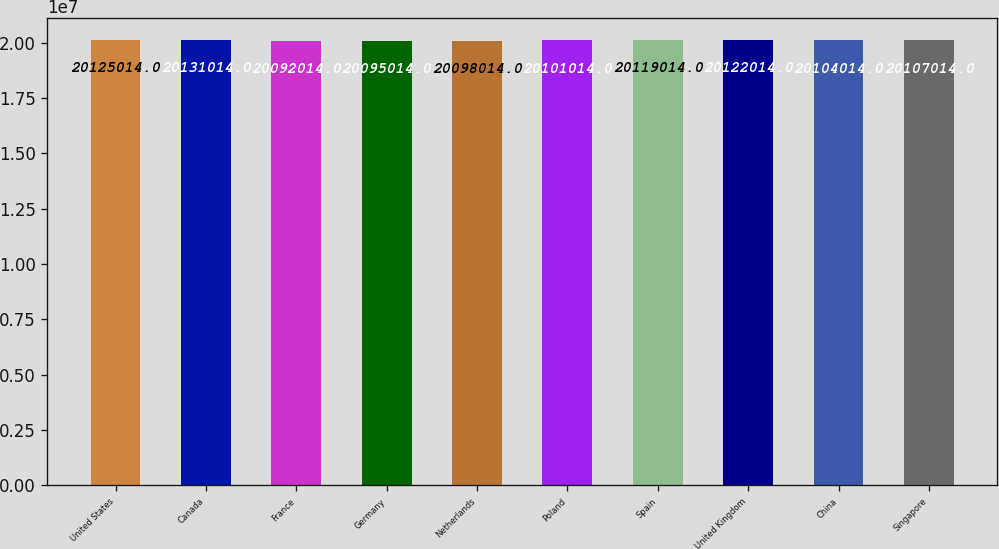Convert chart to OTSL. <chart><loc_0><loc_0><loc_500><loc_500><bar_chart><fcel>United States<fcel>Canada<fcel>France<fcel>Germany<fcel>Netherlands<fcel>Poland<fcel>Spain<fcel>United Kingdom<fcel>China<fcel>Singapore<nl><fcel>2.0125e+07<fcel>2.0131e+07<fcel>2.0092e+07<fcel>2.0095e+07<fcel>2.0098e+07<fcel>2.0101e+07<fcel>2.0119e+07<fcel>2.0122e+07<fcel>2.0104e+07<fcel>2.0107e+07<nl></chart> 